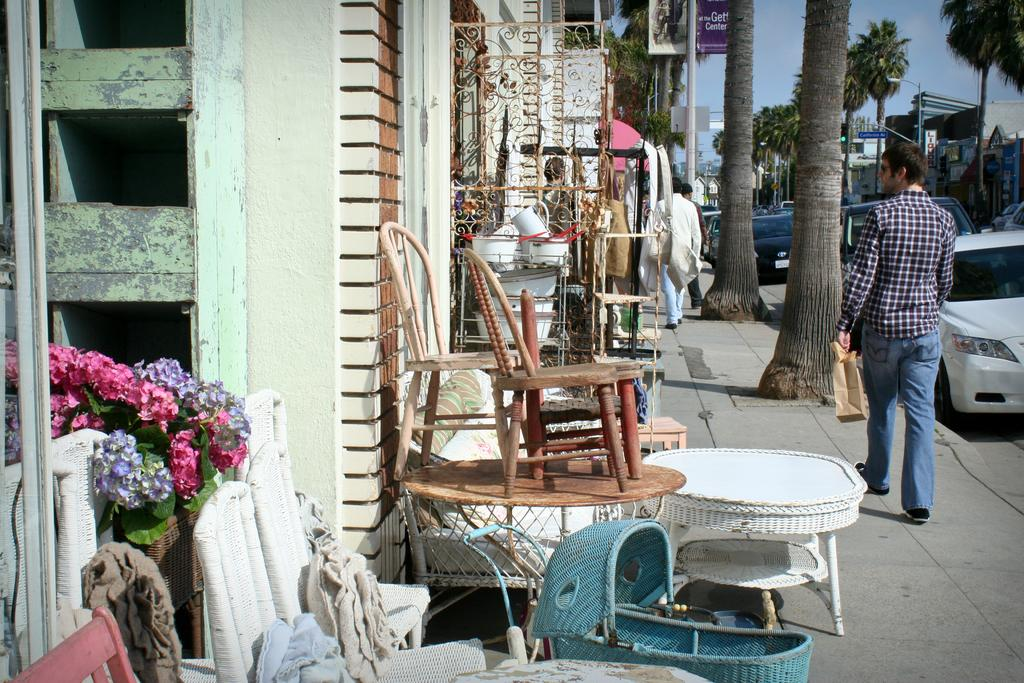What is happening with the group of people in the image? The people are walking on the roadside in the image. What else can be seen in the image besides the group of people? There are chairs and vehicles on the road in the image. What type of toothpaste is being advertised on the billboard in the image? There is no billboard or toothpaste mentioned in the image; it features a group of people walking on the roadside, chairs, and vehicles on the road. 